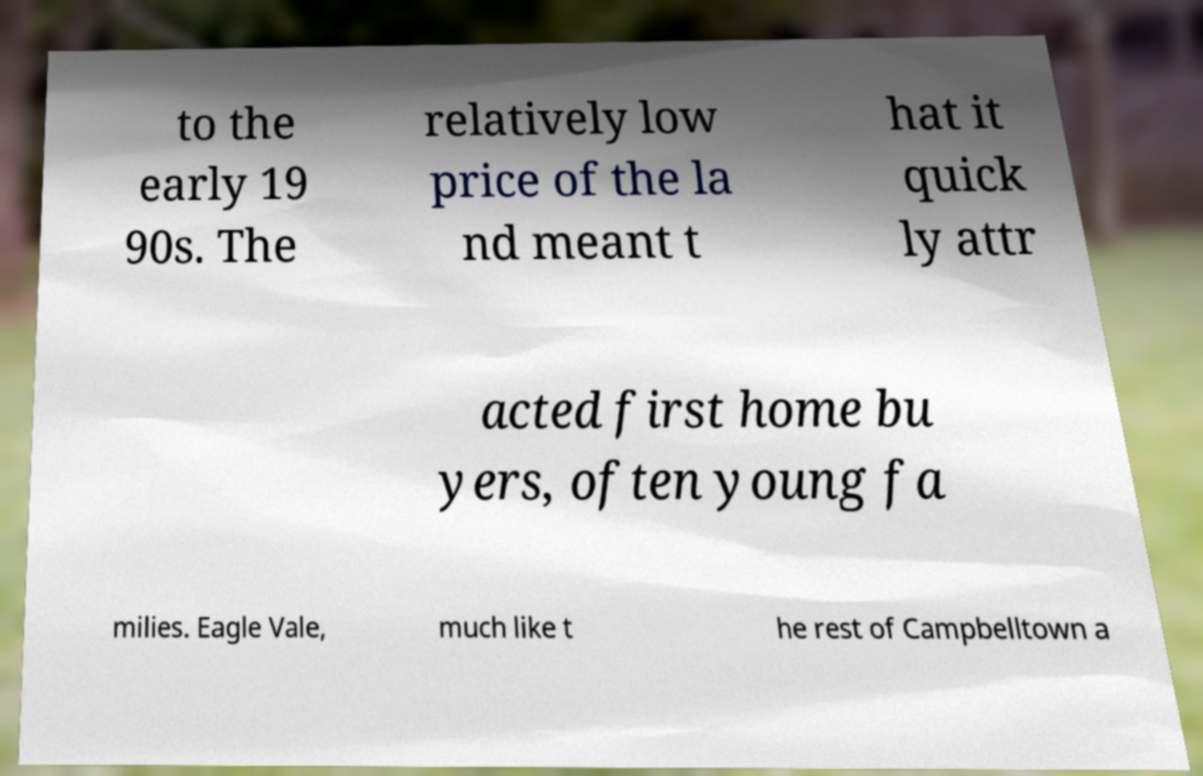Could you extract and type out the text from this image? to the early 19 90s. The relatively low price of the la nd meant t hat it quick ly attr acted first home bu yers, often young fa milies. Eagle Vale, much like t he rest of Campbelltown a 